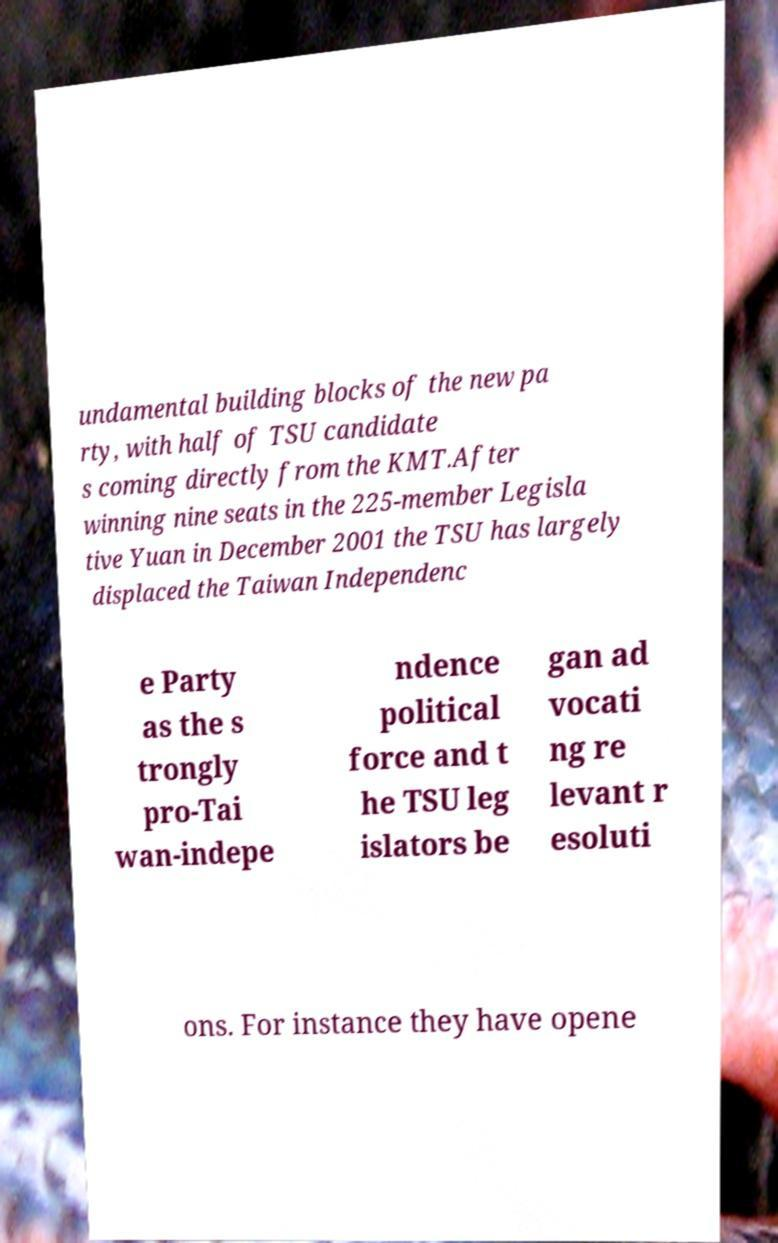Could you assist in decoding the text presented in this image and type it out clearly? undamental building blocks of the new pa rty, with half of TSU candidate s coming directly from the KMT.After winning nine seats in the 225-member Legisla tive Yuan in December 2001 the TSU has largely displaced the Taiwan Independenc e Party as the s trongly pro-Tai wan-indepe ndence political force and t he TSU leg islators be gan ad vocati ng re levant r esoluti ons. For instance they have opene 